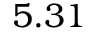<formula> <loc_0><loc_0><loc_500><loc_500>5 . 3 1</formula> 